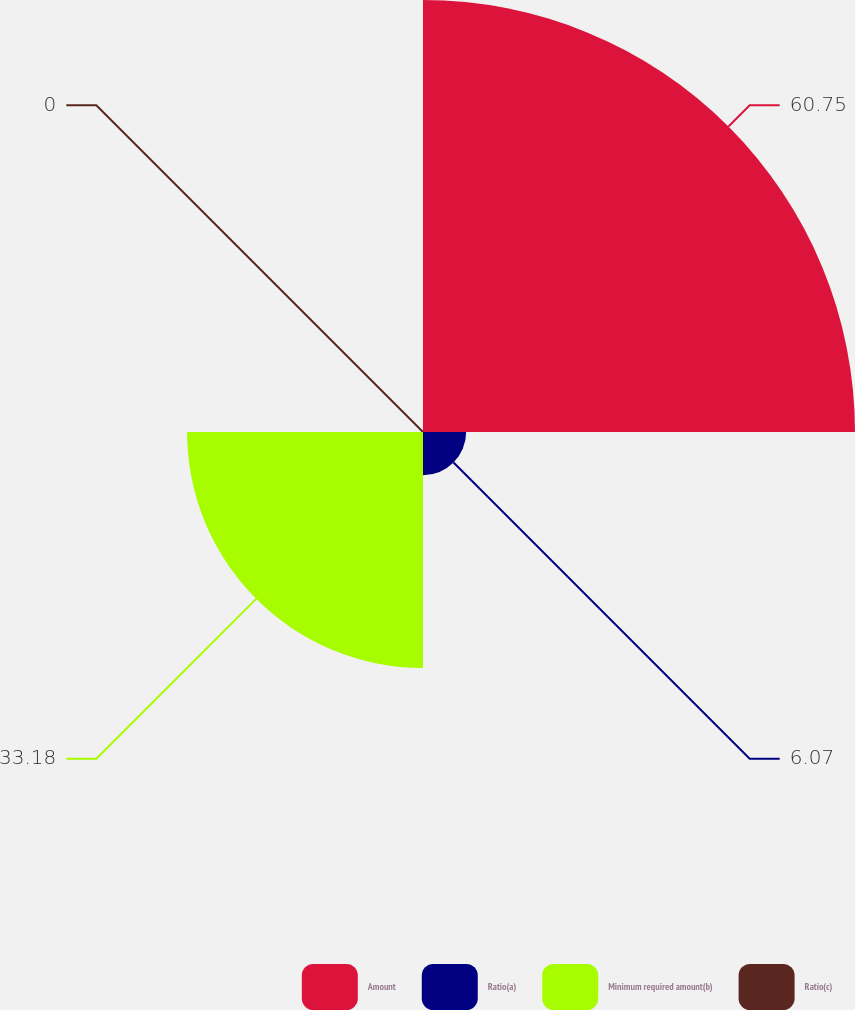Convert chart to OTSL. <chart><loc_0><loc_0><loc_500><loc_500><pie_chart><fcel>Amount<fcel>Ratio(a)<fcel>Minimum required amount(b)<fcel>Ratio(c)<nl><fcel>60.75%<fcel>6.07%<fcel>33.18%<fcel>0.0%<nl></chart> 